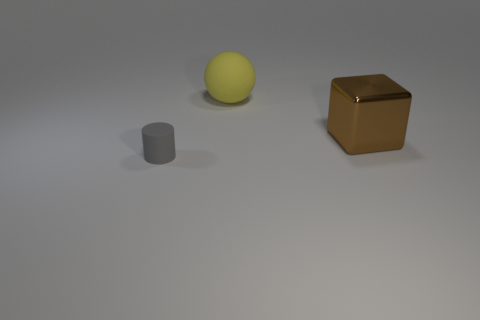How many things are either matte things behind the brown object or purple spheres?
Offer a very short reply. 1. There is a large thing that is in front of the matte thing that is behind the rubber thing that is to the left of the yellow matte sphere; what is it made of?
Your response must be concise. Metal. Is the number of rubber objects that are in front of the brown shiny object greater than the number of tiny cylinders that are right of the large matte sphere?
Your answer should be very brief. Yes. How many spheres are gray metallic objects or yellow rubber things?
Give a very brief answer. 1. What number of brown cubes are behind the rubber thing behind the small rubber thing that is in front of the big yellow thing?
Your answer should be compact. 0. Are there more matte things than tiny gray matte things?
Your answer should be very brief. Yes. Do the gray matte object and the yellow matte thing have the same size?
Your response must be concise. No. What number of things are big brown objects or small blue cylinders?
Give a very brief answer. 1. What shape is the matte thing in front of the large thing that is in front of the rubber object behind the big brown metallic thing?
Give a very brief answer. Cylinder. Do the big yellow thing on the left side of the big shiny thing and the object that is right of the yellow thing have the same material?
Keep it short and to the point. No. 